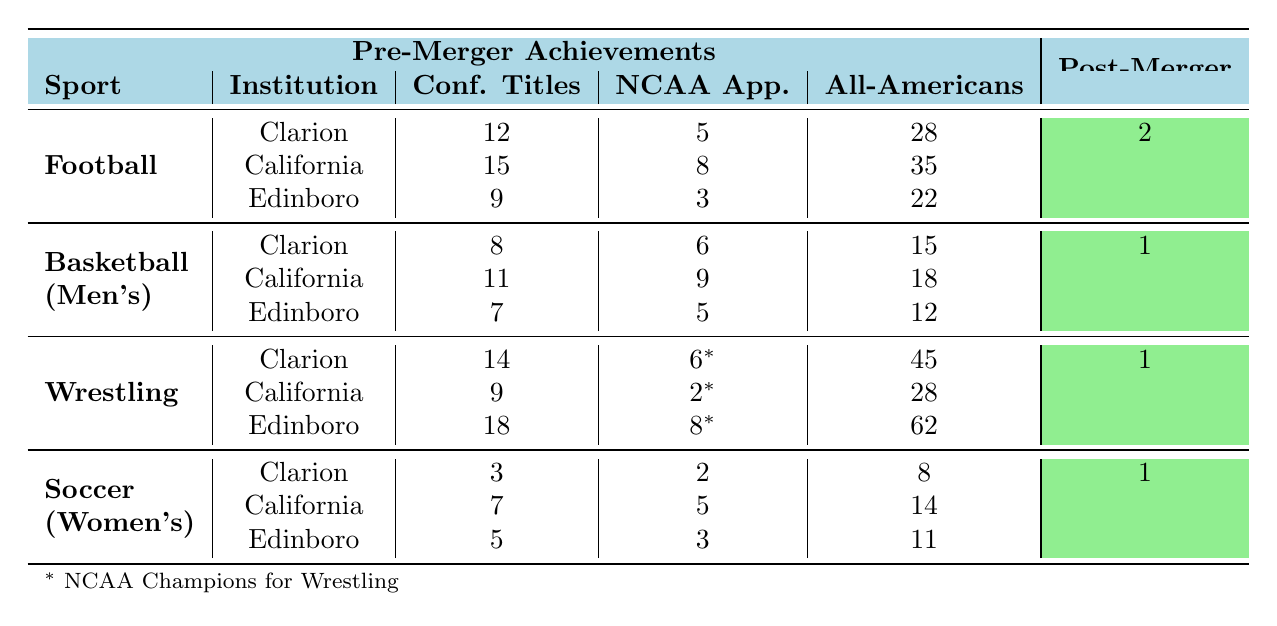What was the total number of NCAA Playoff appearances for the football teams of the pre-merger institutions? The pre-merger institutions had 5 NCAA Playoff appearances from Clarion University, 8 from California University of Pennsylvania, and 3 from Edinboro University. Summing these gives 5 + 8 + 3 = 16 appearances.
Answer: 16 How many All-Americans did the men's basketball teams have before the merger? The pre-merger institutions had 15 All-Americans from Clarion University, 18 from California University of Pennsylvania, and 12 from Edinboro University. Summing these gives 15 + 18 + 12 = 45 All-Americans.
Answer: 45 Did PennWest's wrestling team have more All-Americans after the merger compared to the combined total of the pre-merger institutions? The pre-merger wrestling teams had 45 from Clarion University, 28 from California University of Pennsylvania, and 62 from Edinboro University, adding up to 135 All-Americans. Post-merger, they had 7 All-Americans, which is significantly lower than 135.
Answer: No What is the difference in the number of NCAA Tournament appearances for the men's basketball teams before and after the merger? Before the merger, Clarion had 6, California had 9, and Edinboro had 5 NCAA Tournament appearances, totaling 20 (6 + 9 + 5) appearances. After the merger, there was 1 appearance. The difference is 20 - 1 = 19.
Answer: 19 What sport had the highest number of All-Americans before the merger? For the pre-merger institutions, the highest number of All-Americans was from wrestling which had a total of 135 (45 + 28 + 62). Basketball, in contrast, had 45 (15 + 18 + 12), and football had 85 (28 + 35 + 22).
Answer: Wrestling On average, how many Conference Titles did the women's soccer teams win before the merger? Clarion won 3, California won 7, and Edinboro won 5 Conference Titles, giving a total of 15. There are 3 institutions, so the average is 15 divided by 3, which equals 5.
Answer: 5 Is it true that the football teams had more NCAA Playoff appearances than the men's basketball teams after the merger? Post-merger, the football team had 1 NCAA Playoff appearance while the men's basketball team also had 1 NCAA Tournament appearance. Thus, the two are equal, not one being greater than the other.
Answer: No Which pre-merger institution had the most All-Americans in wrestling? Edinboro University had 62 All-Americans in wrestling, which is higher than Clarion's 45 and California's 28.
Answer: Edinboro University 